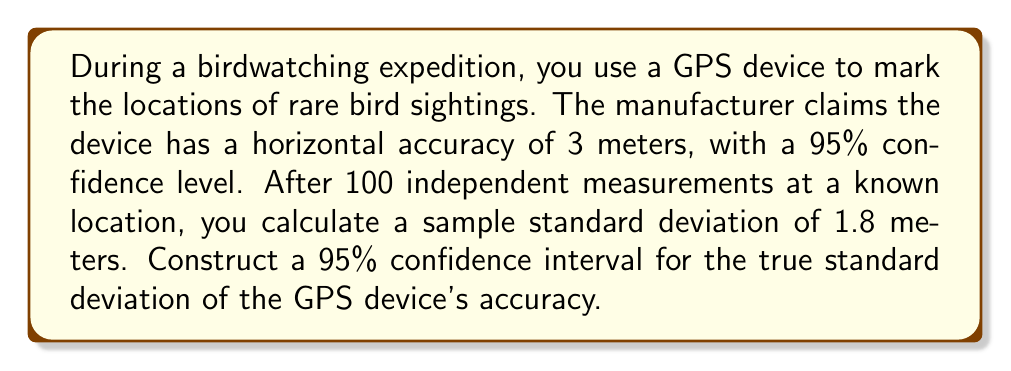Can you solve this math problem? To construct a confidence interval for the population standard deviation, we'll use the chi-square distribution method. Here are the steps:

1. Identify the given information:
   - Sample size: $n = 100$
   - Sample standard deviation: $s = 1.8$ meters
   - Confidence level: 95% (α = 0.05)

2. Find the critical values from the chi-square distribution:
   - Lower critical value: $\chi^2_{0.025, 99} = 73.361$
   - Upper critical value: $\chi^2_{0.975, 99} = 128.422$

3. Use the formula for the confidence interval of the population standard deviation:

   $$\sqrt{\frac{(n-1)s^2}{\chi^2_{1-\alpha/2, n-1}}} < \sigma < \sqrt{\frac{(n-1)s^2}{\chi^2_{\alpha/2, n-1}}}$$

4. Substitute the values:

   $$\sqrt{\frac{99 \cdot 1.8^2}{128.422}} < \sigma < \sqrt{\frac{99 \cdot 1.8^2}{73.361}}$$

5. Simplify:

   $$\sqrt{\frac{320.76}{128.422}} < \sigma < \sqrt{\frac{320.76}{73.361}}$$

6. Calculate the final result:

   $$1.58 < \sigma < 2.09$$

Therefore, we can be 95% confident that the true standard deviation of the GPS device's accuracy lies between 1.58 meters and 2.09 meters.
Answer: (1.58 m, 2.09 m) 